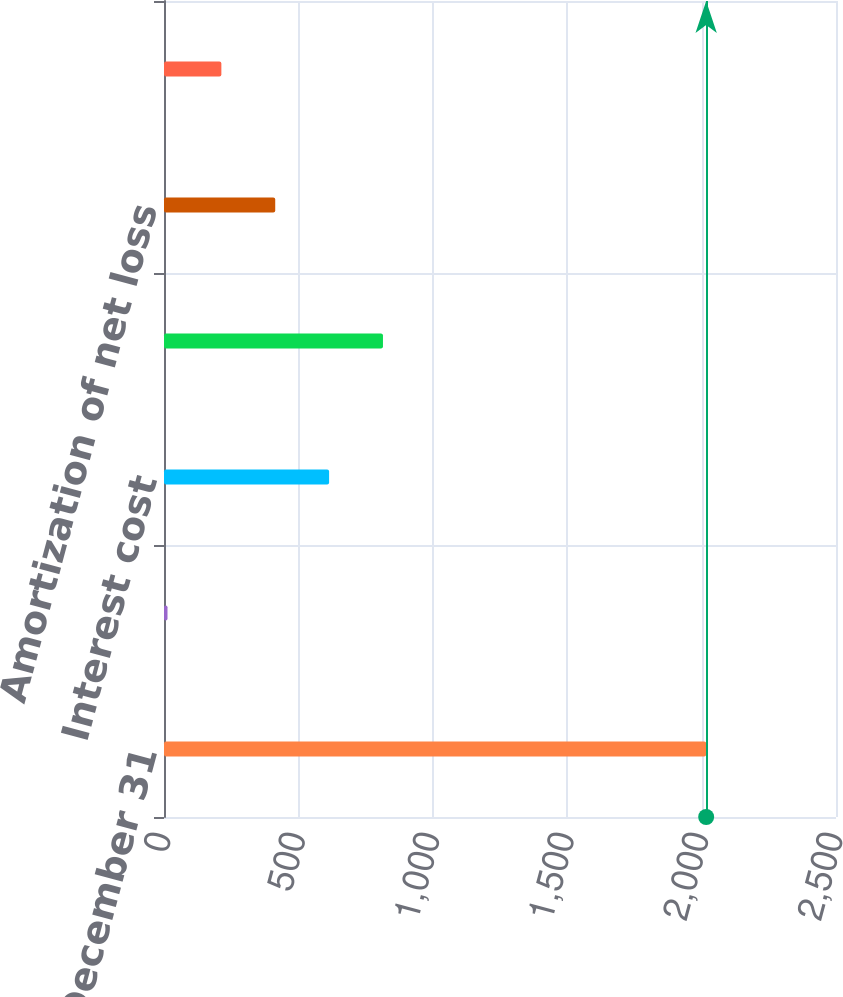Convert chart to OTSL. <chart><loc_0><loc_0><loc_500><loc_500><bar_chart><fcel>December 31<fcel>Service cost<fcel>Interest cost<fcel>Expected return on plan assets<fcel>Amortization of net loss<fcel>Total pension cost<nl><fcel>2017<fcel>13<fcel>614.2<fcel>814.6<fcel>413.8<fcel>213.4<nl></chart> 